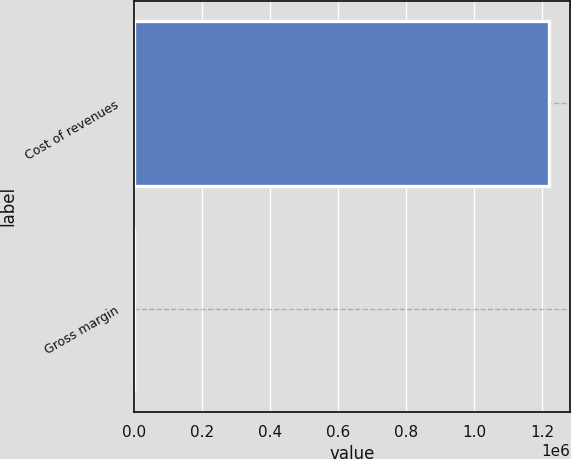Convert chart to OTSL. <chart><loc_0><loc_0><loc_500><loc_500><bar_chart><fcel>Cost of revenues<fcel>Gross margin<nl><fcel>1.22033e+06<fcel>79<nl></chart> 